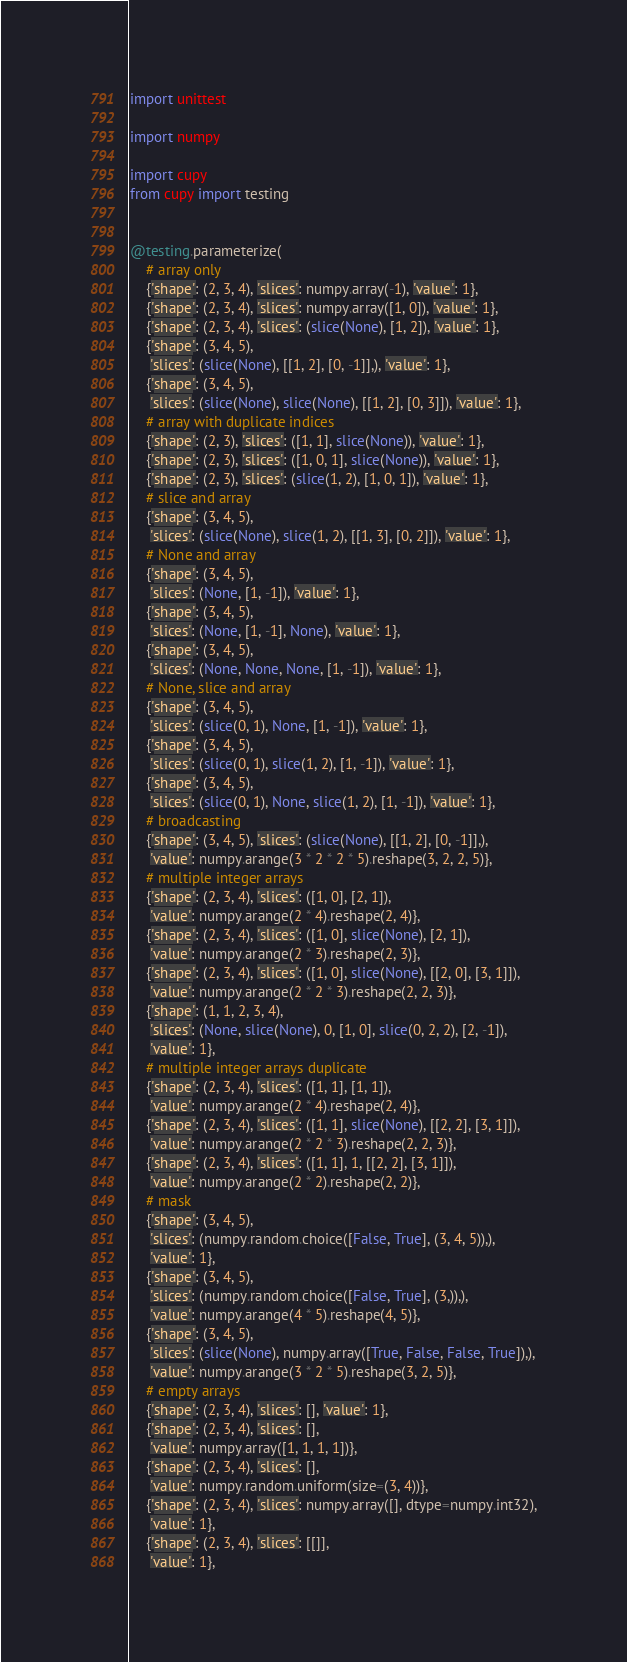Convert code to text. <code><loc_0><loc_0><loc_500><loc_500><_Python_>import unittest

import numpy

import cupy
from cupy import testing


@testing.parameterize(
    # array only
    {'shape': (2, 3, 4), 'slices': numpy.array(-1), 'value': 1},
    {'shape': (2, 3, 4), 'slices': numpy.array([1, 0]), 'value': 1},
    {'shape': (2, 3, 4), 'slices': (slice(None), [1, 2]), 'value': 1},
    {'shape': (3, 4, 5),
     'slices': (slice(None), [[1, 2], [0, -1]],), 'value': 1},
    {'shape': (3, 4, 5),
     'slices': (slice(None), slice(None), [[1, 2], [0, 3]]), 'value': 1},
    # array with duplicate indices
    {'shape': (2, 3), 'slices': ([1, 1], slice(None)), 'value': 1},
    {'shape': (2, 3), 'slices': ([1, 0, 1], slice(None)), 'value': 1},
    {'shape': (2, 3), 'slices': (slice(1, 2), [1, 0, 1]), 'value': 1},
    # slice and array
    {'shape': (3, 4, 5),
     'slices': (slice(None), slice(1, 2), [[1, 3], [0, 2]]), 'value': 1},
    # None and array
    {'shape': (3, 4, 5),
     'slices': (None, [1, -1]), 'value': 1},
    {'shape': (3, 4, 5),
     'slices': (None, [1, -1], None), 'value': 1},
    {'shape': (3, 4, 5),
     'slices': (None, None, None, [1, -1]), 'value': 1},
    # None, slice and array
    {'shape': (3, 4, 5),
     'slices': (slice(0, 1), None, [1, -1]), 'value': 1},
    {'shape': (3, 4, 5),
     'slices': (slice(0, 1), slice(1, 2), [1, -1]), 'value': 1},
    {'shape': (3, 4, 5),
     'slices': (slice(0, 1), None, slice(1, 2), [1, -1]), 'value': 1},
    # broadcasting
    {'shape': (3, 4, 5), 'slices': (slice(None), [[1, 2], [0, -1]],),
     'value': numpy.arange(3 * 2 * 2 * 5).reshape(3, 2, 2, 5)},
    # multiple integer arrays
    {'shape': (2, 3, 4), 'slices': ([1, 0], [2, 1]),
     'value': numpy.arange(2 * 4).reshape(2, 4)},
    {'shape': (2, 3, 4), 'slices': ([1, 0], slice(None), [2, 1]),
     'value': numpy.arange(2 * 3).reshape(2, 3)},
    {'shape': (2, 3, 4), 'slices': ([1, 0], slice(None), [[2, 0], [3, 1]]),
     'value': numpy.arange(2 * 2 * 3).reshape(2, 2, 3)},
    {'shape': (1, 1, 2, 3, 4),
     'slices': (None, slice(None), 0, [1, 0], slice(0, 2, 2), [2, -1]),
     'value': 1},
    # multiple integer arrays duplicate
    {'shape': (2, 3, 4), 'slices': ([1, 1], [1, 1]),
     'value': numpy.arange(2 * 4).reshape(2, 4)},
    {'shape': (2, 3, 4), 'slices': ([1, 1], slice(None), [[2, 2], [3, 1]]),
     'value': numpy.arange(2 * 2 * 3).reshape(2, 2, 3)},
    {'shape': (2, 3, 4), 'slices': ([1, 1], 1, [[2, 2], [3, 1]]),
     'value': numpy.arange(2 * 2).reshape(2, 2)},
    # mask
    {'shape': (3, 4, 5),
     'slices': (numpy.random.choice([False, True], (3, 4, 5)),),
     'value': 1},
    {'shape': (3, 4, 5),
     'slices': (numpy.random.choice([False, True], (3,)),),
     'value': numpy.arange(4 * 5).reshape(4, 5)},
    {'shape': (3, 4, 5),
     'slices': (slice(None), numpy.array([True, False, False, True]),),
     'value': numpy.arange(3 * 2 * 5).reshape(3, 2, 5)},
    # empty arrays
    {'shape': (2, 3, 4), 'slices': [], 'value': 1},
    {'shape': (2, 3, 4), 'slices': [],
     'value': numpy.array([1, 1, 1, 1])},
    {'shape': (2, 3, 4), 'slices': [],
     'value': numpy.random.uniform(size=(3, 4))},
    {'shape': (2, 3, 4), 'slices': numpy.array([], dtype=numpy.int32),
     'value': 1},
    {'shape': (2, 3, 4), 'slices': [[]],
     'value': 1},</code> 